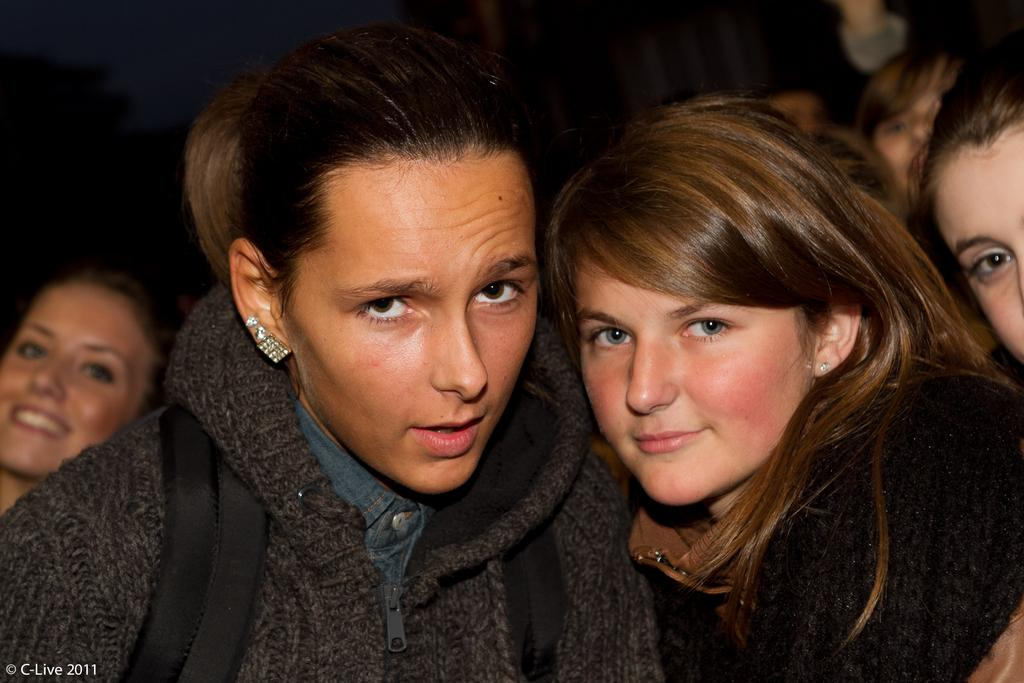What is the main subject of the image? The main subject of the image is a group of people. Can you describe the background of the image? The background of the image is blurred. Is there any additional information or marking on the image? Yes, there is a watermark on the image. What type of food is being shared among the group of people in the image? There is no food visible in the image, so it cannot be determined what, if any, food is being shared among the group. 